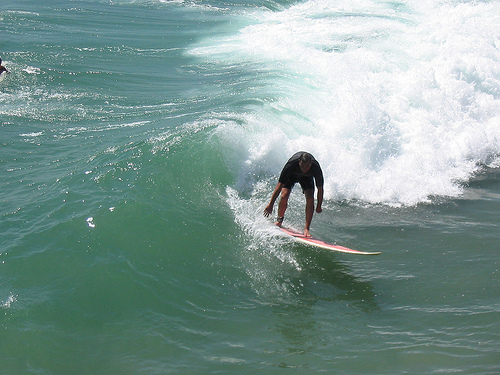Create a story around the surfer in the image, detailing their background and what led them to this moment. The surfer in the image is Alex, a 28-year-old professional surfer originally from a small coastal town. Alex fell in love with the ocean at a young age, spending countless hours honing his skills on the waves he grew up with. After winning numerous local competitions, he decided to pursue surfing professionally, traveling to some of the world's most famous surfing spots. This image captures Alex at the peak of his career, in the midst of an exhilarating competition on the beautiful waves of Hawaii. The intense focus and determination on his face reflect years of dedication and passion for the sport, as he rides the wave with precision and grace, a testament to his journey from amateur to professional surfer. Using your wildest imagination, what fantastical element could be added to this scene? Imagine if instead of riding a typical wave, the surfer is gliding atop the back of a massive, friendly sea dragon. The dragon's blue and green scales shimmer in the sunlight, blending seamlessly with the ocean waves. As it peaks out of the water, the dragon creates enormous waves, providing an ultimate playground for the surfer. Together, they perform synchronized dances atop the waves, embodying a harmonious relationship between human and mythical sea creature. Spectators on the shore watch in awe as the duo navigates the water with unmatched grace and wonder. 